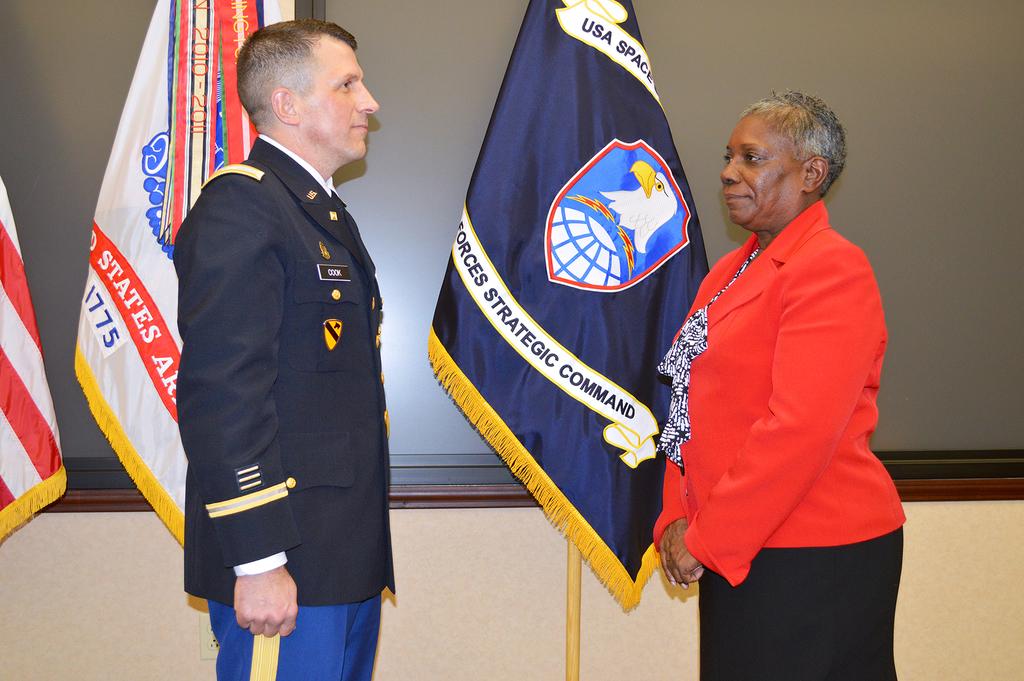What country are the flags from?
Give a very brief answer. Usa. What type of command is displayed on blue flag?
Your answer should be very brief. Strategic. 